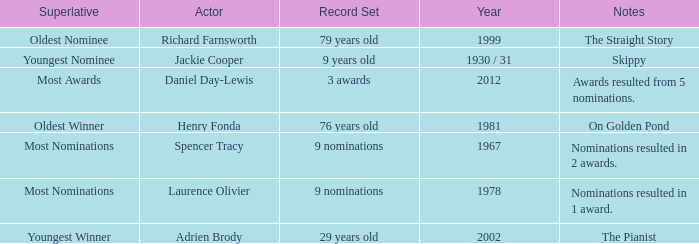What year was the the youngest nominee a winner? 1930 / 31. Would you mind parsing the complete table? {'header': ['Superlative', 'Actor', 'Record Set', 'Year', 'Notes'], 'rows': [['Oldest Nominee', 'Richard Farnsworth', '79 years old', '1999', 'The Straight Story'], ['Youngest Nominee', 'Jackie Cooper', '9 years old', '1930 / 31', 'Skippy'], ['Most Awards', 'Daniel Day-Lewis', '3 awards', '2012', 'Awards resulted from 5 nominations.'], ['Oldest Winner', 'Henry Fonda', '76 years old', '1981', 'On Golden Pond'], ['Most Nominations', 'Spencer Tracy', '9 nominations', '1967', 'Nominations resulted in 2 awards.'], ['Most Nominations', 'Laurence Olivier', '9 nominations', '1978', 'Nominations resulted in 1 award.'], ['Youngest Winner', 'Adrien Brody', '29 years old', '2002', 'The Pianist']]} 